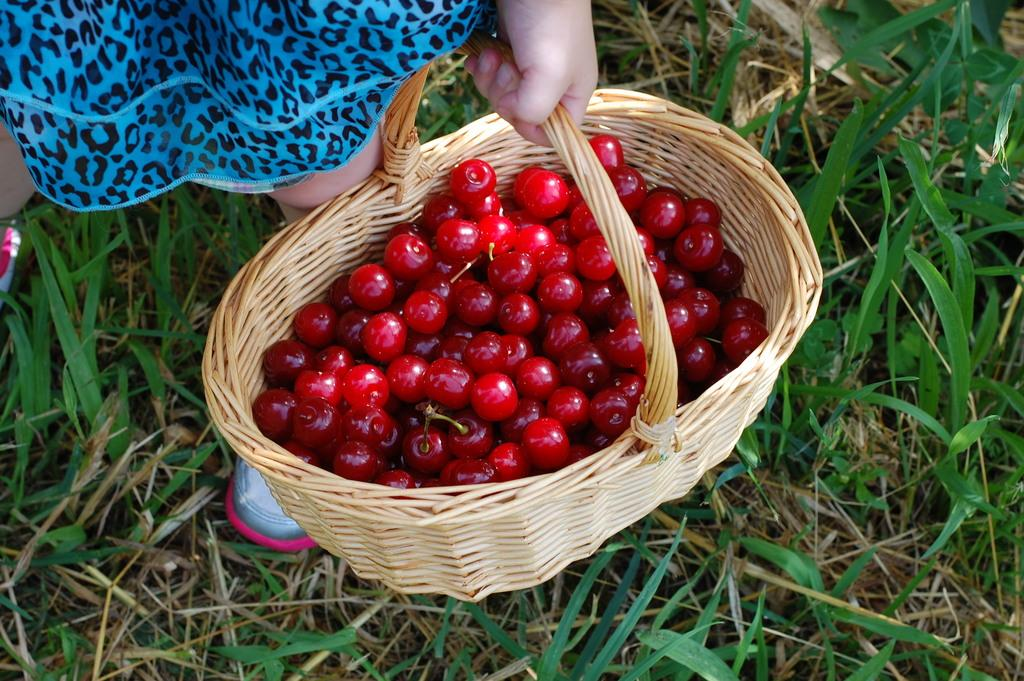What is the main subject of the picture? There is a human in the picture. What is the human holding in the picture? The human is holding a basket. What is inside the basket? There are cherries in the basket. What type of surface is visible on the ground? There is grass on the ground. How many clocks can be seen hanging from the trees in the image? There are no clocks visible in the image; it features a human holding a basket of cherries on a grassy surface. What type of wind can be felt blowing through the cherries in the basket? There is no wind present in the image, as it is focused on the human holding the basket of cherries on a grassy surface. 